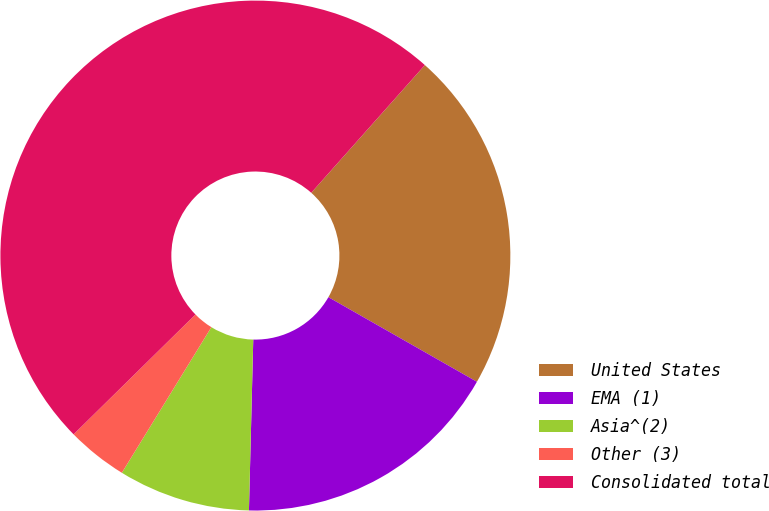<chart> <loc_0><loc_0><loc_500><loc_500><pie_chart><fcel>United States<fcel>EMA (1)<fcel>Asia^(2)<fcel>Other (3)<fcel>Consolidated total<nl><fcel>21.67%<fcel>17.16%<fcel>8.37%<fcel>3.86%<fcel>48.94%<nl></chart> 